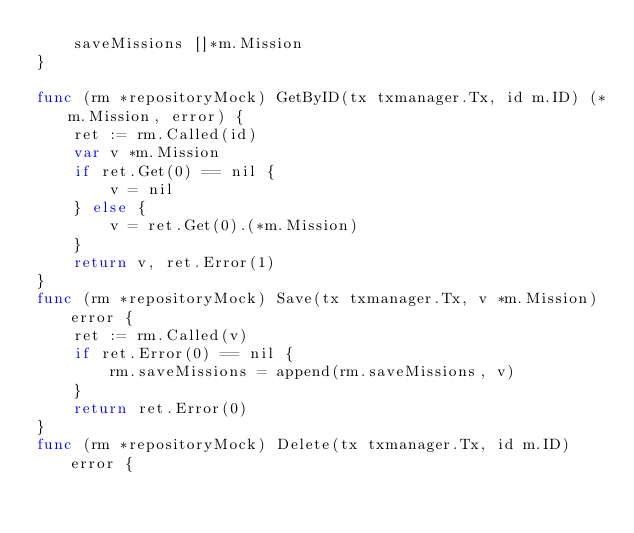<code> <loc_0><loc_0><loc_500><loc_500><_Go_>	saveMissions []*m.Mission
}

func (rm *repositoryMock) GetByID(tx txmanager.Tx, id m.ID) (*m.Mission, error) {
	ret := rm.Called(id)
	var v *m.Mission
	if ret.Get(0) == nil {
		v = nil
	} else {
		v = ret.Get(0).(*m.Mission)
	}
	return v, ret.Error(1)
}
func (rm *repositoryMock) Save(tx txmanager.Tx, v *m.Mission) error {
	ret := rm.Called(v)
	if ret.Error(0) == nil {
		rm.saveMissions = append(rm.saveMissions, v)
	}
	return ret.Error(0)
}
func (rm *repositoryMock) Delete(tx txmanager.Tx, id m.ID) error {</code> 